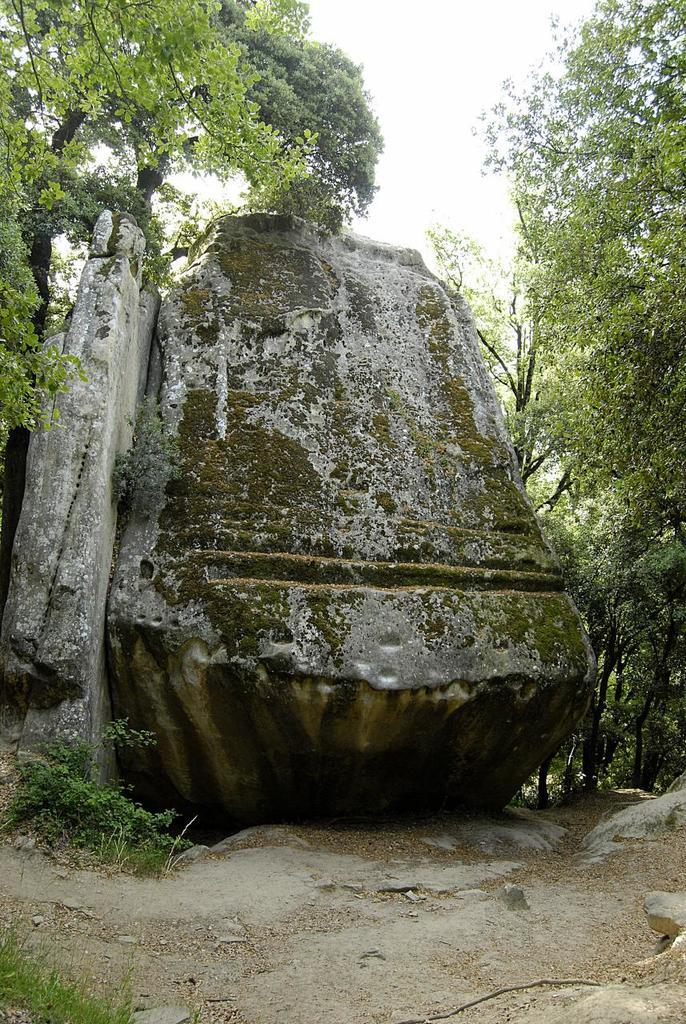What type of natural elements can be seen in the image? There are rocks and trees in the image. What is visible in the background of the image? There is a sky visible in the image. Are there any plants present in the image? Yes, there are few plants in the image. What shape is the quilt that is covering the rocks in the image? There is no quilt present in the image, and the rocks are not covered. What type of test can be seen being conducted in the image? There is no test being conducted in the image. 